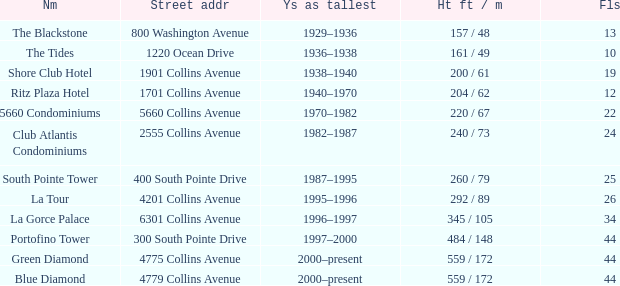How many floors does the Blue Diamond have? 44.0. 